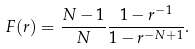Convert formula to latex. <formula><loc_0><loc_0><loc_500><loc_500>F ( r ) = \frac { N - 1 } { N } \frac { 1 - r ^ { - 1 } } { 1 - r ^ { - N + 1 } } .</formula> 